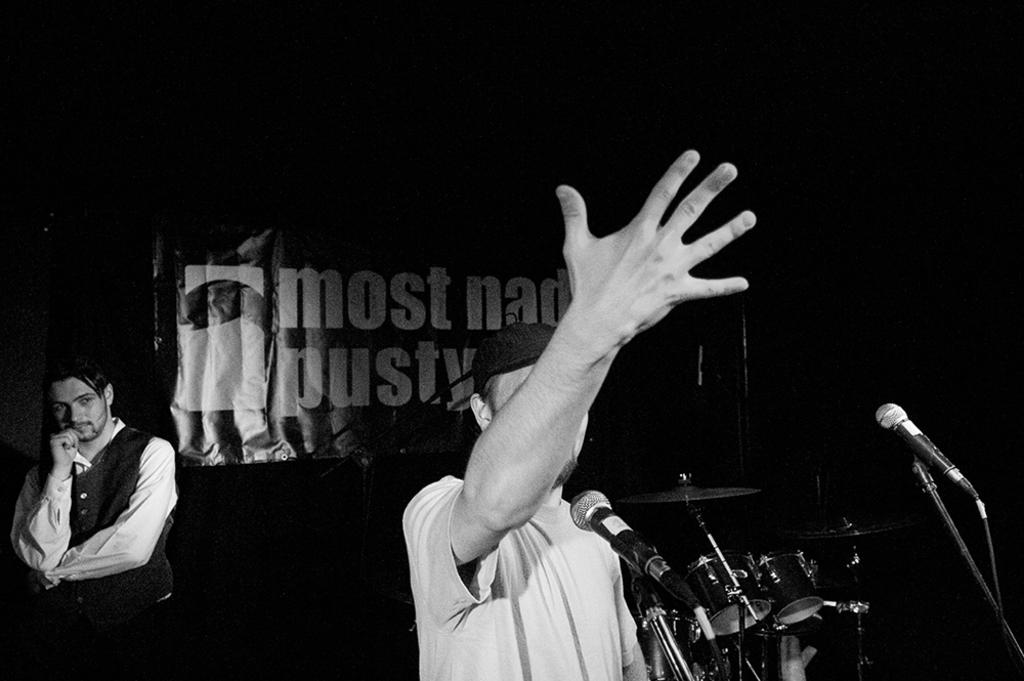What objects are in the foreground of the picture? There are mics and drums in the foreground of the picture. Who or what can be seen in the foreground of the picture? There is a person in the foreground of the picture. Can you describe the person standing on the left side of the picture? There is a person standing on the left side of the picture. What is in the middle of the picture? There is a banner in the middle of the picture. How would you describe the lighting in the top part of the image? The top part of the image is dark. What type of brick is being used to build the governor's regret in the image? There is no brick, governor, or regret present in the image. 